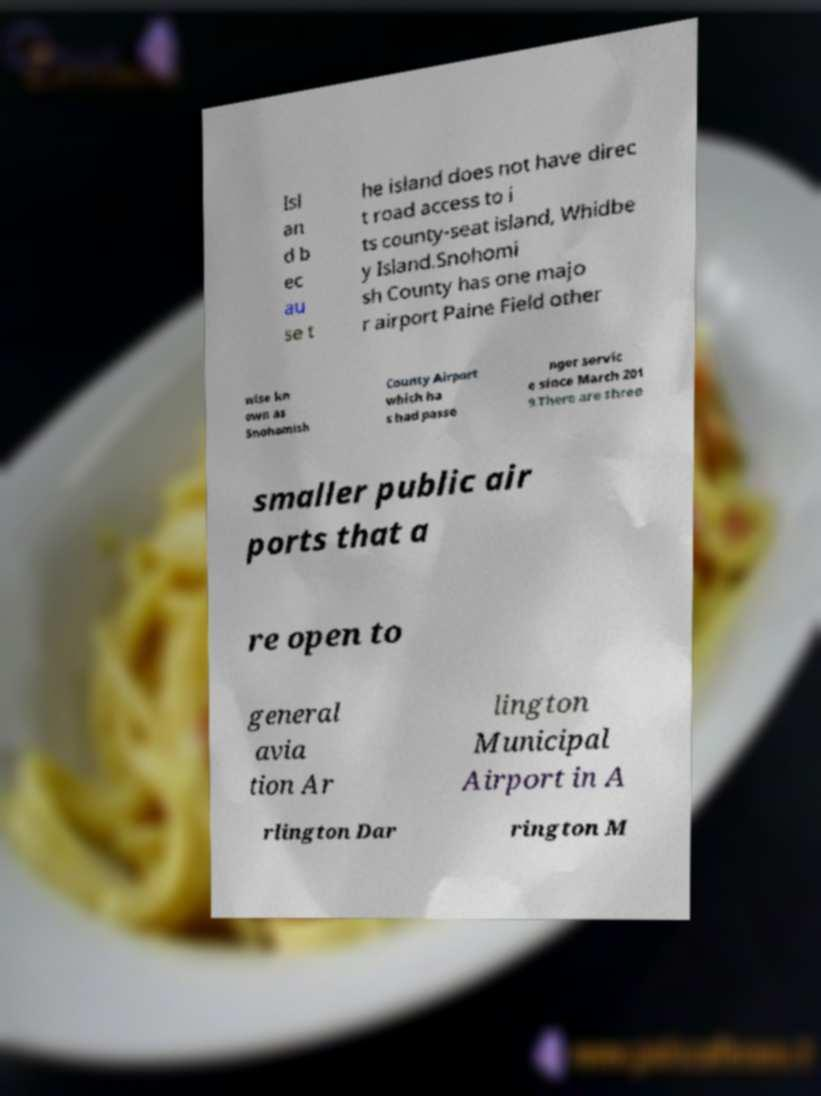Could you assist in decoding the text presented in this image and type it out clearly? Isl an d b ec au se t he island does not have direc t road access to i ts county-seat island, Whidbe y Island.Snohomi sh County has one majo r airport Paine Field other wise kn own as Snohomish County Airport which ha s had passe nger servic e since March 201 9.There are three smaller public air ports that a re open to general avia tion Ar lington Municipal Airport in A rlington Dar rington M 